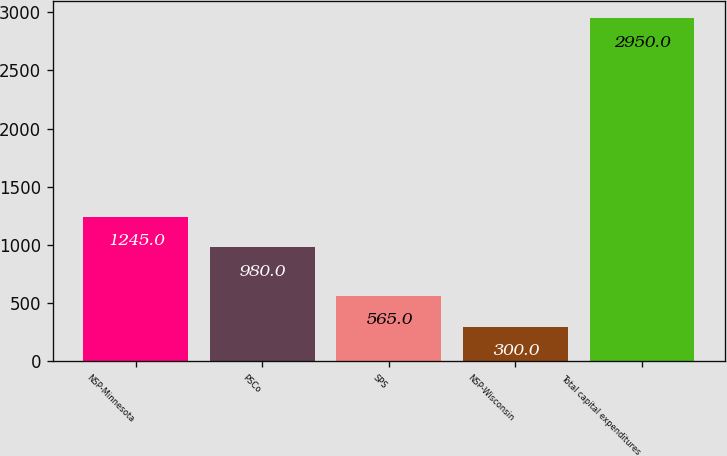Convert chart to OTSL. <chart><loc_0><loc_0><loc_500><loc_500><bar_chart><fcel>NSP-Minnesota<fcel>PSCo<fcel>SPS<fcel>NSP-Wisconsin<fcel>Total capital expenditures<nl><fcel>1245<fcel>980<fcel>565<fcel>300<fcel>2950<nl></chart> 